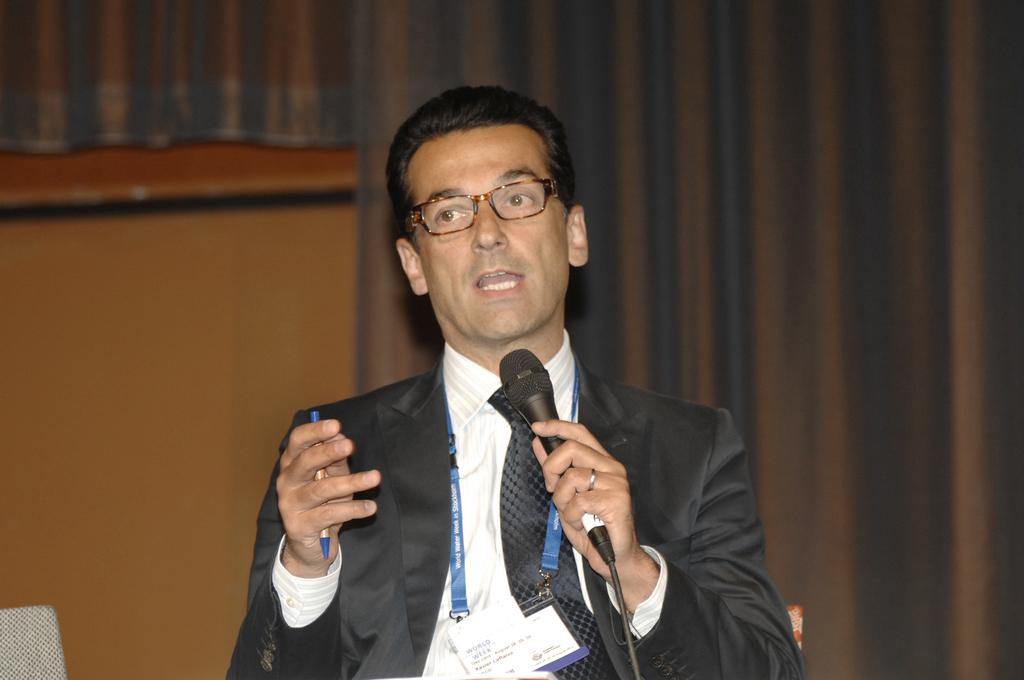What is the main subject of the image? There is a man standing in the center of the image. What is the man holding in his hands? The man is holding a pen in his hands. What can be seen in the background of the image? There is a curtain and a wall in the background of the image. How many jellyfish are swimming in the background of the image? There are no jellyfish present in the image; the background features a curtain and a wall. What type of stone is the man holding in his hand? The man is not holding a stone in his hand; he is holding a pen. 